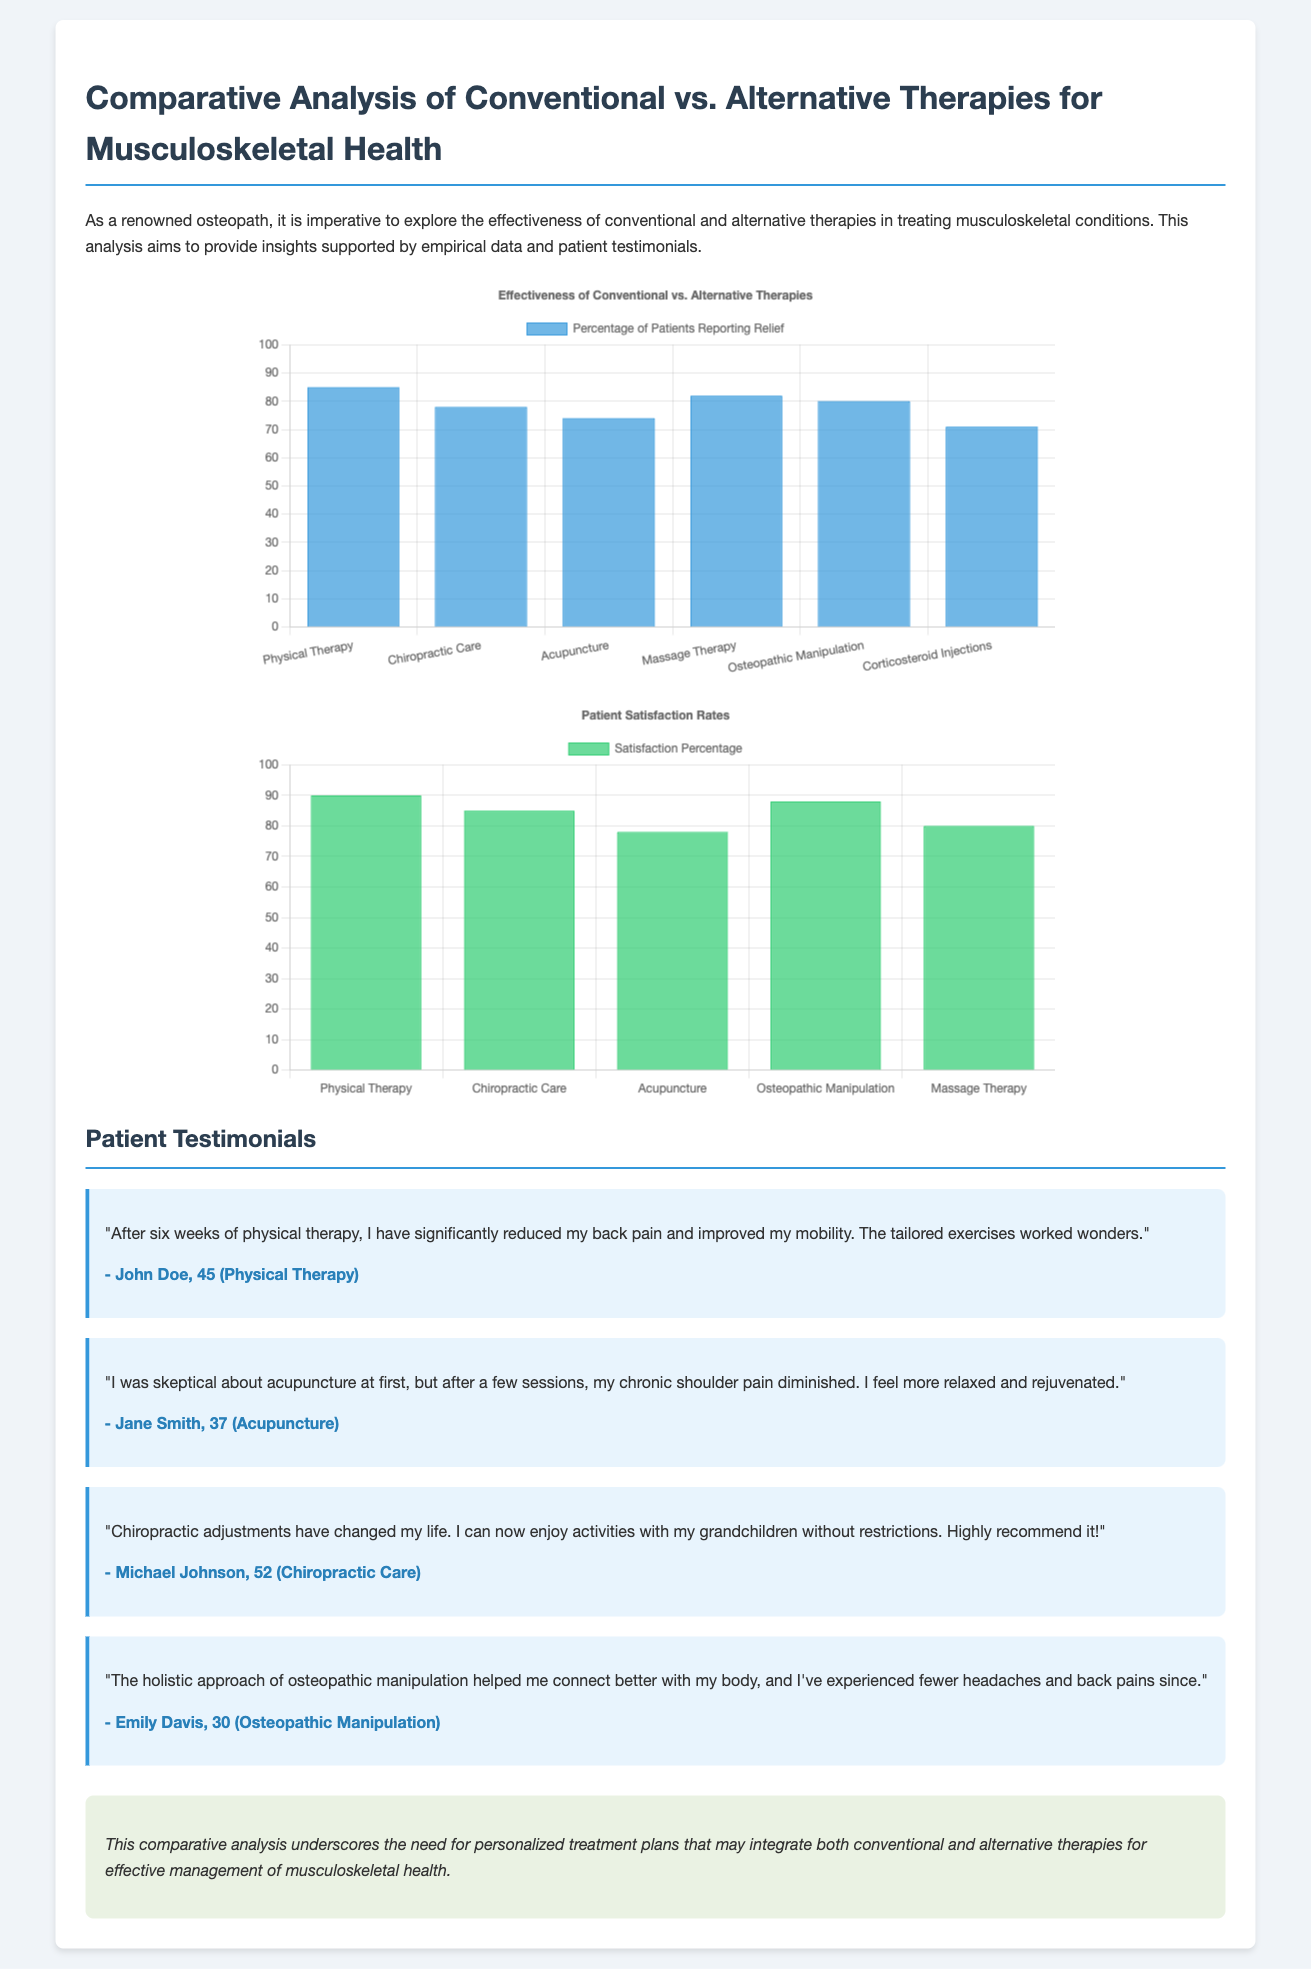What is the title of the document? The title provides the main focus of the analysis presented in the document, which is prominently displayed at the top.
Answer: Comparative Analysis of Conventional vs. Alternative Therapies for Musculoskeletal Health What therapy had the highest percentage of patients reporting relief? The effectiveness chart lists the therapies by percentage, making it clear which one had the highest reported relief.
Answer: Physical Therapy What is the satisfaction percentage for Osteopathic Manipulation? The satisfaction chart specifies the percentage for this particular therapy, which can be found alongside others.
Answer: 88 Which therapy ranked lowest in patient satisfaction? The satisfaction chart indicates the comparison of different therapies, showing which one had the lowest percentage.
Answer: Acupuncture How many testimonials are provided in the document? The document lists a number of personal experiences from patients, which can be counted directly for the total.
Answer: 4 What percentage of patients reported relief from Chiropractic Care? The effectiveness chart provides specific data on relief percentages for each therapy, including Chiropractic Care.
Answer: 78 What background color is used for patient testimonials? The document describes the design elements used for presenting testimonials, including their background color.
Answer: Light blue What is the main recommendation in the conclusion? The conclusion summarizes the findings of the analysis and suggests an approach for treatment, evident in the last paragraph.
Answer: Personalized treatment plans 